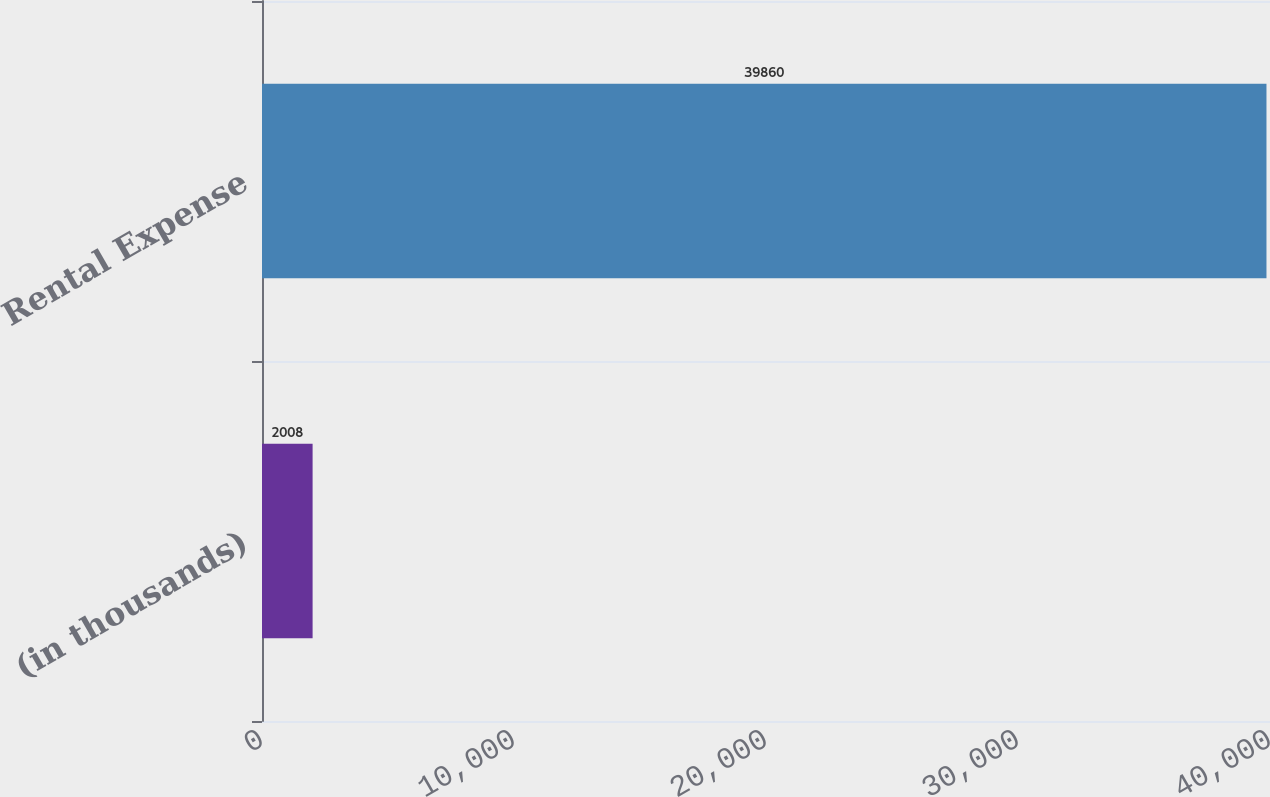Convert chart to OTSL. <chart><loc_0><loc_0><loc_500><loc_500><bar_chart><fcel>(in thousands)<fcel>Rental Expense<nl><fcel>2008<fcel>39860<nl></chart> 